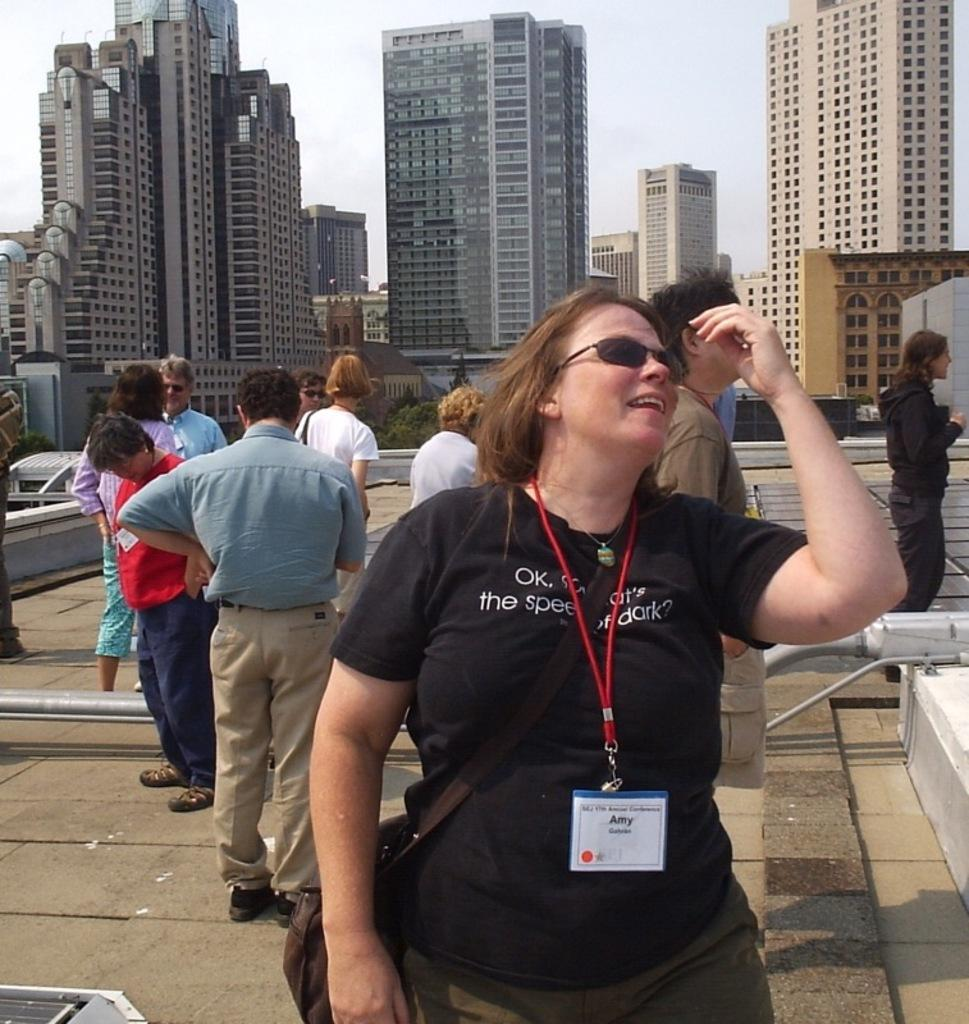How many people are in the image? A: There is a group of people in the image, but the exact number is not specified. What are the people in the image doing? The people are standing in the image. What can be seen in the background of the image? There are buildings and the sky visible in the background of the image. Can you hear the whistle of the wind in the image? There is no mention of wind or a whistle in the image, so it cannot be heard. 